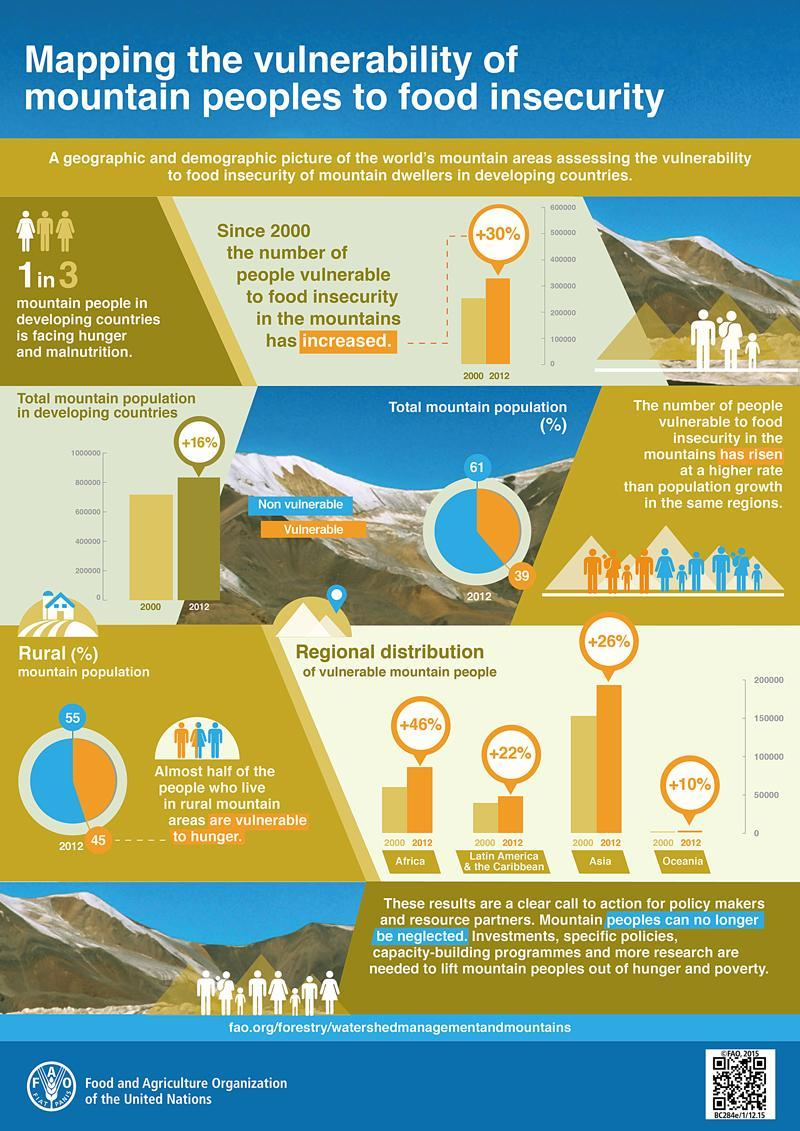What is the percentage increase of total mountain population in developing countries in 2012?
Answer the question with a short phrase. 16% In which year, there is 46% increase of vulnerable mountain people in Africa? 2012 What percentage of total mountain population in developing countries are vulnerable to hunger in 2012? 39 What percentage of total mountain population in developing countries are non-vulnerable to hunger in 2012? 61 What percentage of people living in rural mountain areas of developing countries are non-vulnerable to hunger in 2012? 55 What percentage of people living in rural mountain areas of developing countries are vulnerable to hunger in 2012? 45 What percentage of vulnerable mountain people has increased in Asia in 2012? +26% 